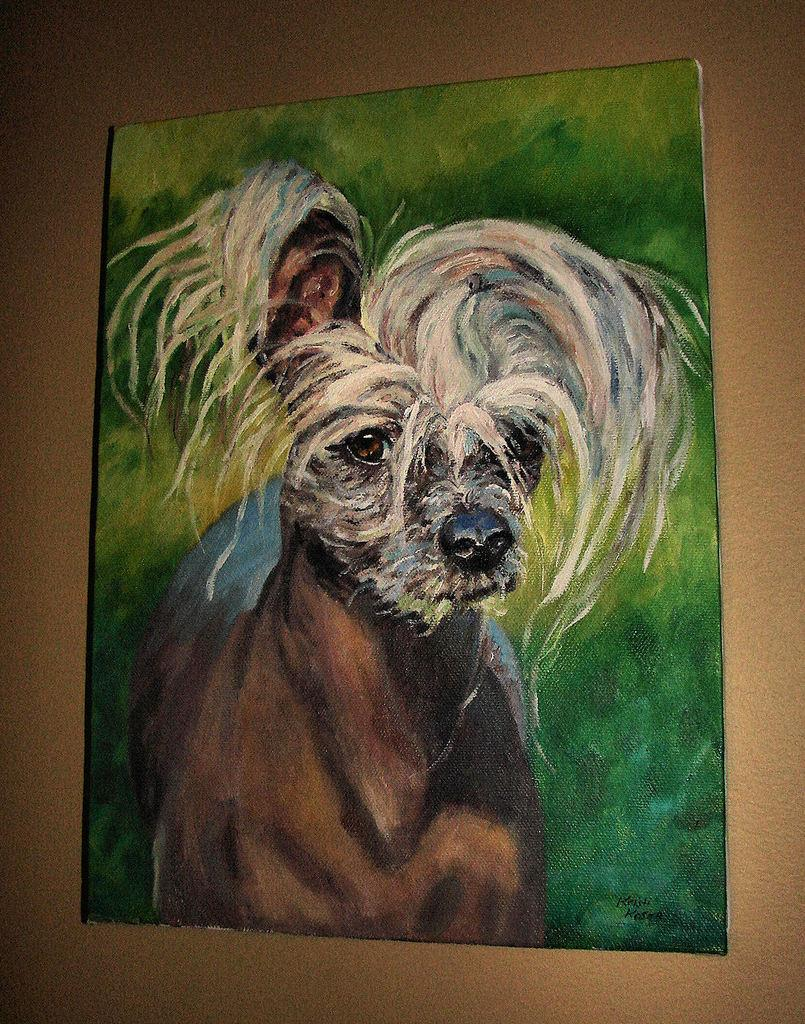What is attached to the wall in the image? There is a frame attached to the wall in the image. What is the color of the wall? The wall is brown in color. What is inside the frame? The frame contains a painting. What is the subject of the painting? The painting depicts a dog. What type of air is being used to inflate the dog in the painting? There is no air being used to inflate the dog in the painting; it is a two-dimensional representation of a dog. 